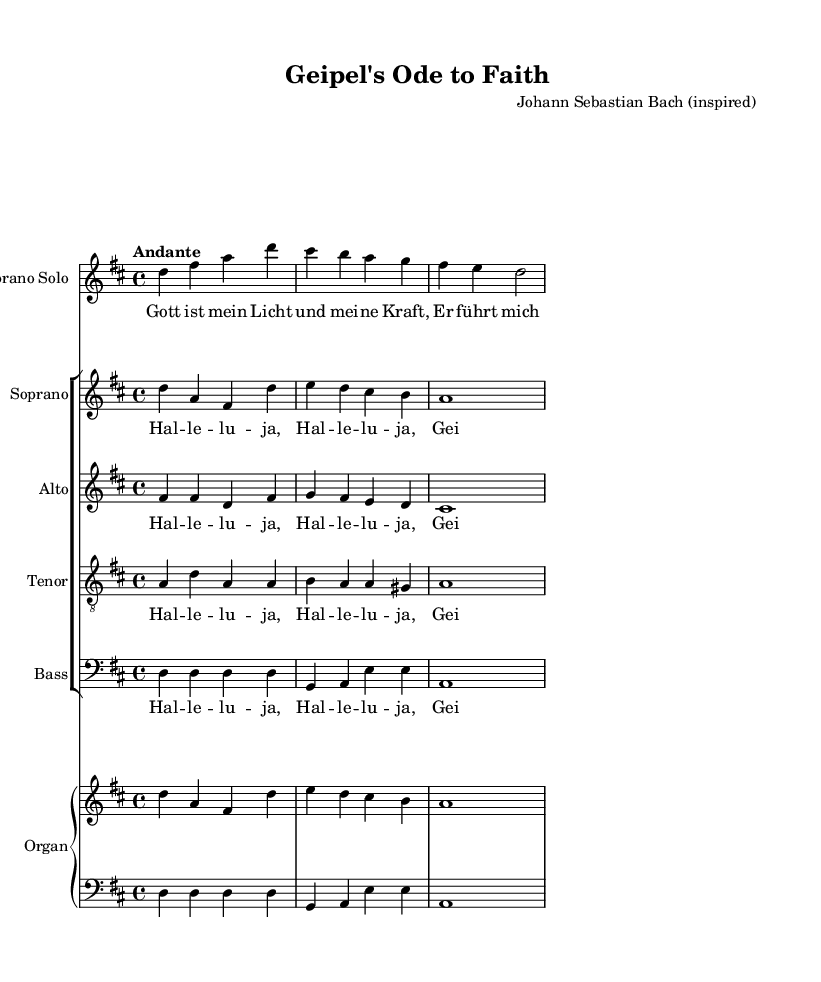What is the key signature of this music? The key signature is D major, which has two sharps (F# and C#). This can be identified at the beginning of the music sheet, where the key signature is displayed.
Answer: D major What is the time signature of this music? The time signature is 4/4, which indicates there are four beats in each measure. This is clearly stated at the start of the sheet music.
Answer: 4/4 What is the tempo marking of this piece? The tempo marking is "Andante," which indicates a moderate walking pace. This can be found in the tempo section of the score.
Answer: Andante How many voices are present in the choir? There are five voices present: soprano solo, soprano, alto, tenor, and bass. Counting each distinct staff for the voices in the choir confirms this.
Answer: Five How does the soprano solo verse begin? The soprano solo verse begins with "Gott ist mein Licht und mei -- ne Kraft," which is shown in the lyrics directly under the soprano solo part in the score.
Answer: Gott ist mein Licht und mei -- ne Kraft What is the primary theme expressed in the chorus? The primary theme expressed in the chorus is praise, specifically indicated by the repeated "Hal -- le -- lu -- ja." This is evident from the lyrics provided for the choir parts.
Answer: Hal -- le -- lu -- ja What is the role of the organ in this piece? The organ supports the choir and solo parts, acting as an accompaniment. This is understood by observing the dedicated "Organ" staff and its placement in the score.
Answer: Accompaniment 